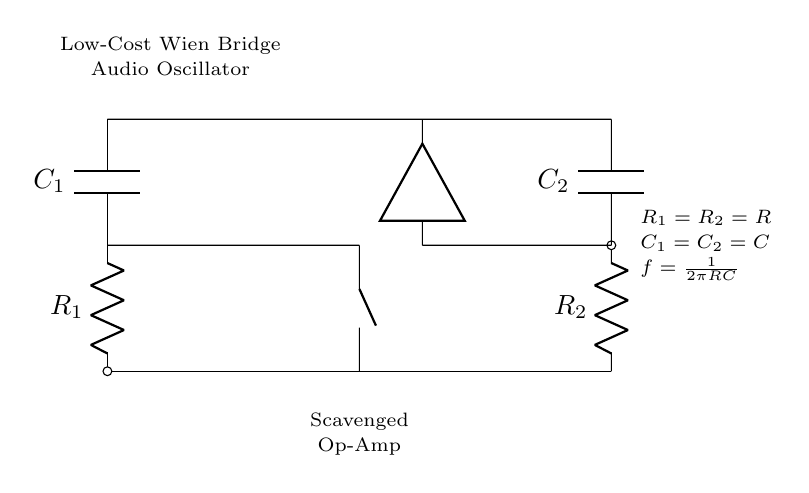What type of circuit is this? This is a Wien bridge oscillator circuit. It is designed to generate sine waves at specific frequencies using resistors and capacitors. The presence of two resistors and two capacitors in the circuit is characteristic of a Wien bridge configuration.
Answer: Wien bridge oscillator How many resistors are in the circuit? There are two resistors labeled R1 and R2 in the circuit, both of which are used to balance the bridge and set the frequency of the oscillator.
Answer: 2 What is the role of the capacitors in this circuit? The capacitors C1 and C2 are essential for determining the frequency of oscillation. They, along with the resistors, set the time constant for the circuit, which influences the frequency through the formula f = 1/(2πRC).
Answer: Set frequency What is the condition for oscillation in this Wien bridge circuit? For oscillation to occur in this Wien bridge circuit, the ratio of the resistors R1 and R2 must be equal, and the capacitors must also be equal, which allows the circuit to maintain a stable oscillation condition.
Answer: Equal resistors and capacitors What is the frequency formula for this circuit? The frequency of oscillation can be calculated using the formula f = 1/(2πRC), where R refers to the resistance in ohms and C refers to the capacitance in farads. This shows how resistance and capacitance interact to produce frequency.
Answer: f = 1/(2πRC) What component is required for amplification in this circuit? An operational amplifier (op-amp) is needed to amplify the signal and maintain oscillations in the circuit. The circuit diagram indicates the presence of a scavenged op-amp, demonstrating a low-cost solution.
Answer: Op-amp 